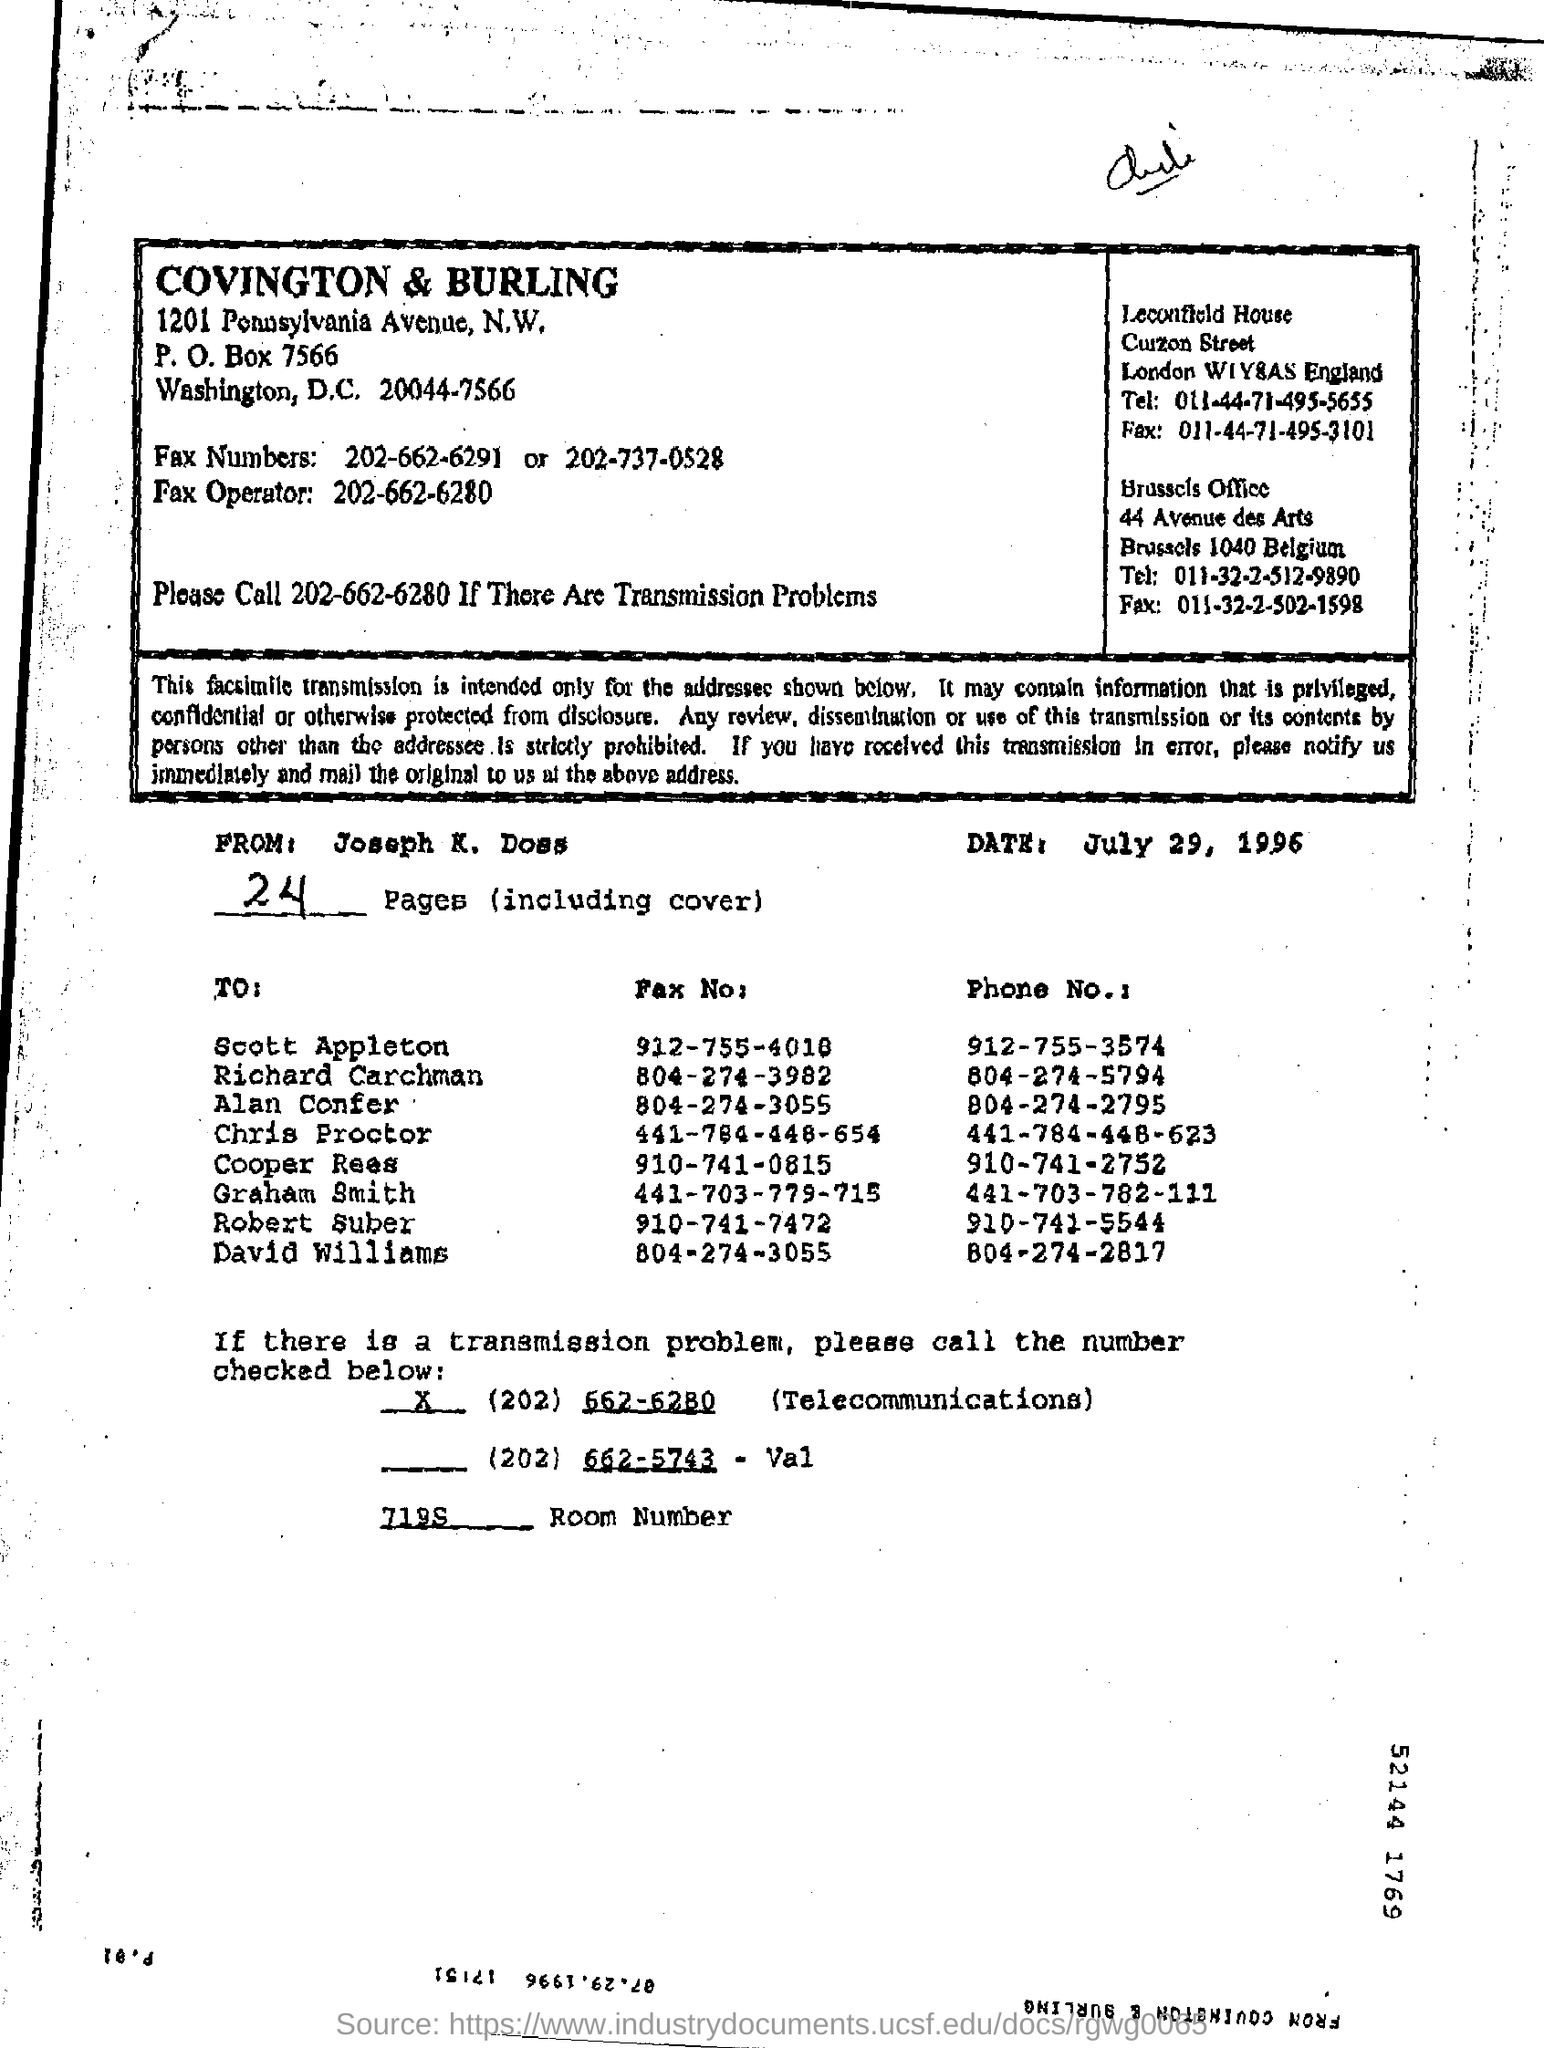Give some essential details in this illustration. The Brussels office is located in 44 Avenue des Arts. The phone number of Graham Smith is 441-703-782-111. The telephone number of the Brussels office is 011-32-2-512-9890. The number of the room is 7195. The post box number of COBNVINGTON & BURLING is 7566. 